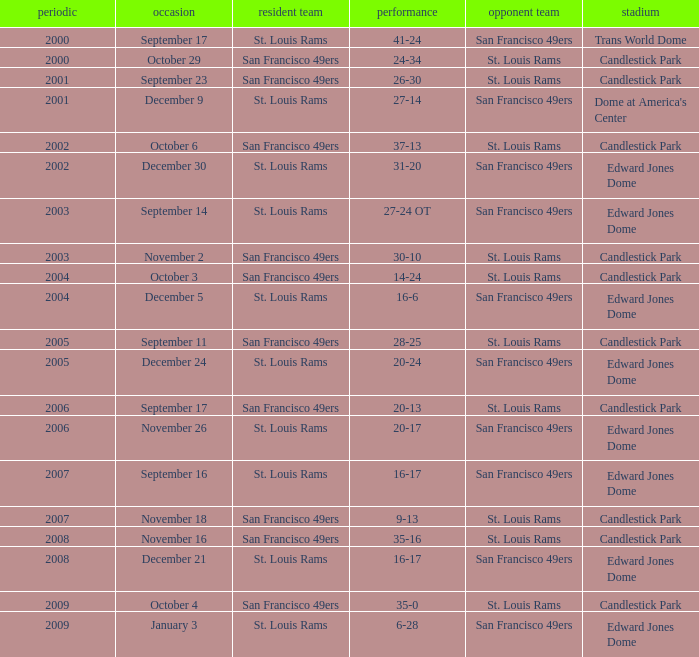What Date after 2007 had the San Francisco 49ers as the Visiting Team? December 21, January 3. Give me the full table as a dictionary. {'header': ['periodic', 'occasion', 'resident team', 'performance', 'opponent team', 'stadium'], 'rows': [['2000', 'September 17', 'St. Louis Rams', '41-24', 'San Francisco 49ers', 'Trans World Dome'], ['2000', 'October 29', 'San Francisco 49ers', '24-34', 'St. Louis Rams', 'Candlestick Park'], ['2001', 'September 23', 'San Francisco 49ers', '26-30', 'St. Louis Rams', 'Candlestick Park'], ['2001', 'December 9', 'St. Louis Rams', '27-14', 'San Francisco 49ers', "Dome at America's Center"], ['2002', 'October 6', 'San Francisco 49ers', '37-13', 'St. Louis Rams', 'Candlestick Park'], ['2002', 'December 30', 'St. Louis Rams', '31-20', 'San Francisco 49ers', 'Edward Jones Dome'], ['2003', 'September 14', 'St. Louis Rams', '27-24 OT', 'San Francisco 49ers', 'Edward Jones Dome'], ['2003', 'November 2', 'San Francisco 49ers', '30-10', 'St. Louis Rams', 'Candlestick Park'], ['2004', 'October 3', 'San Francisco 49ers', '14-24', 'St. Louis Rams', 'Candlestick Park'], ['2004', 'December 5', 'St. Louis Rams', '16-6', 'San Francisco 49ers', 'Edward Jones Dome'], ['2005', 'September 11', 'San Francisco 49ers', '28-25', 'St. Louis Rams', 'Candlestick Park'], ['2005', 'December 24', 'St. Louis Rams', '20-24', 'San Francisco 49ers', 'Edward Jones Dome'], ['2006', 'September 17', 'San Francisco 49ers', '20-13', 'St. Louis Rams', 'Candlestick Park'], ['2006', 'November 26', 'St. Louis Rams', '20-17', 'San Francisco 49ers', 'Edward Jones Dome'], ['2007', 'September 16', 'St. Louis Rams', '16-17', 'San Francisco 49ers', 'Edward Jones Dome'], ['2007', 'November 18', 'San Francisco 49ers', '9-13', 'St. Louis Rams', 'Candlestick Park'], ['2008', 'November 16', 'San Francisco 49ers', '35-16', 'St. Louis Rams', 'Candlestick Park'], ['2008', 'December 21', 'St. Louis Rams', '16-17', 'San Francisco 49ers', 'Edward Jones Dome'], ['2009', 'October 4', 'San Francisco 49ers', '35-0', 'St. Louis Rams', 'Candlestick Park'], ['2009', 'January 3', 'St. Louis Rams', '6-28', 'San Francisco 49ers', 'Edward Jones Dome']]} 